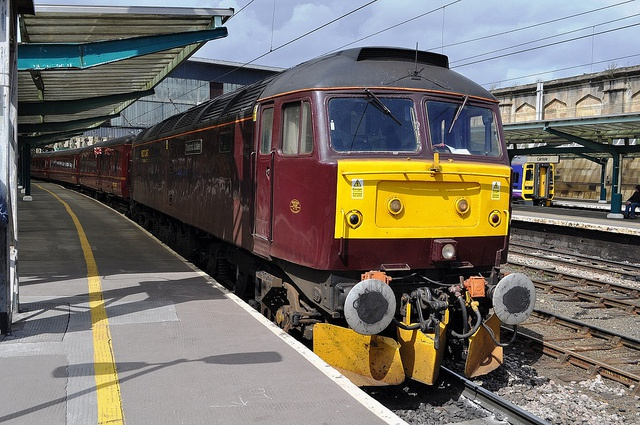Describe the objects in this image and their specific colors. I can see train in black, gray, maroon, and gold tones, train in black, gray, olive, and khaki tones, and people in black, navy, gray, and darkgray tones in this image. 